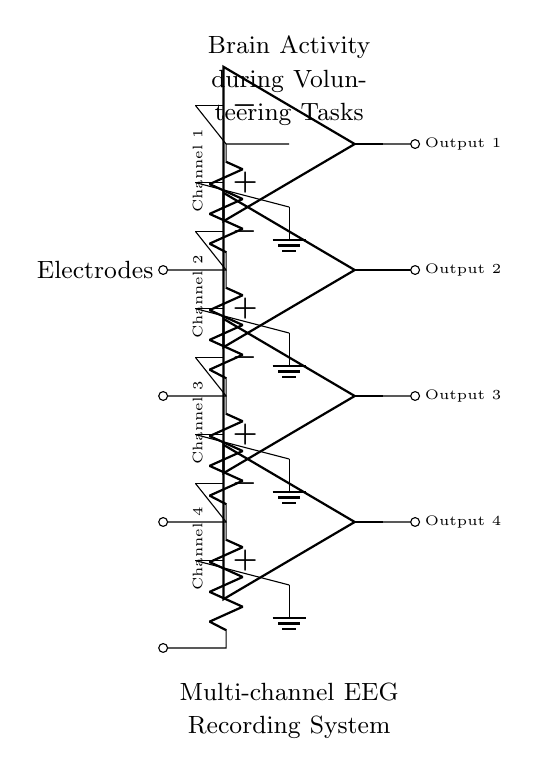What type of circuit is depicted here? The circuit is a multi-channel EEG recording system that uses parallel connections to monitor brain activity. A parallel circuit configuration is indicated by the multiple channels connected to a common node at the electrodes.
Answer: parallel How many channels are represented in the circuit? There are four channels represented in the circuit diagram, each indicated by a resistor labeled as Channel 1, Channel 2, Channel 3, and Channel 4.
Answer: four What do the amplifiers in the circuit do? The amplifiers in the circuit enhance the signals received from each channel's electrodes, ensuring the brain activity data can be accurately recorded and analyzed. Each amplifier corresponds to a specific channel from which it receives input.
Answer: enhance signals What is the purpose of the ground connections in the circuit? The ground connections provide a reference point for the voltage levels in the circuit, ensuring stability and reducing noise in the measurements. This grounding allows for consistent and accurate readings from the EEG electrodes through the amplifiers.
Answer: provide reference Which elements indicate the output of the EEG signals? The output of the EEG signals is indicated by the lines terminating at Output 1, Output 2, Output 3, and Output 4, all connected to the respective amplifiers. Each output represents the processed signal from its associated channel.
Answer: Output 1, Output 2, Output 3, Output 4 Why is it useful to have multiple channels in an EEG recording system? Multiple channels are useful in an EEG recording system because they allow for the simultaneous monitoring of different areas of the brain, providing a comprehensive view of brain activity during volunteering tasks. This multi-channel setup can capture diverse electrical activities from various brain regions.
Answer: comprehensive view 